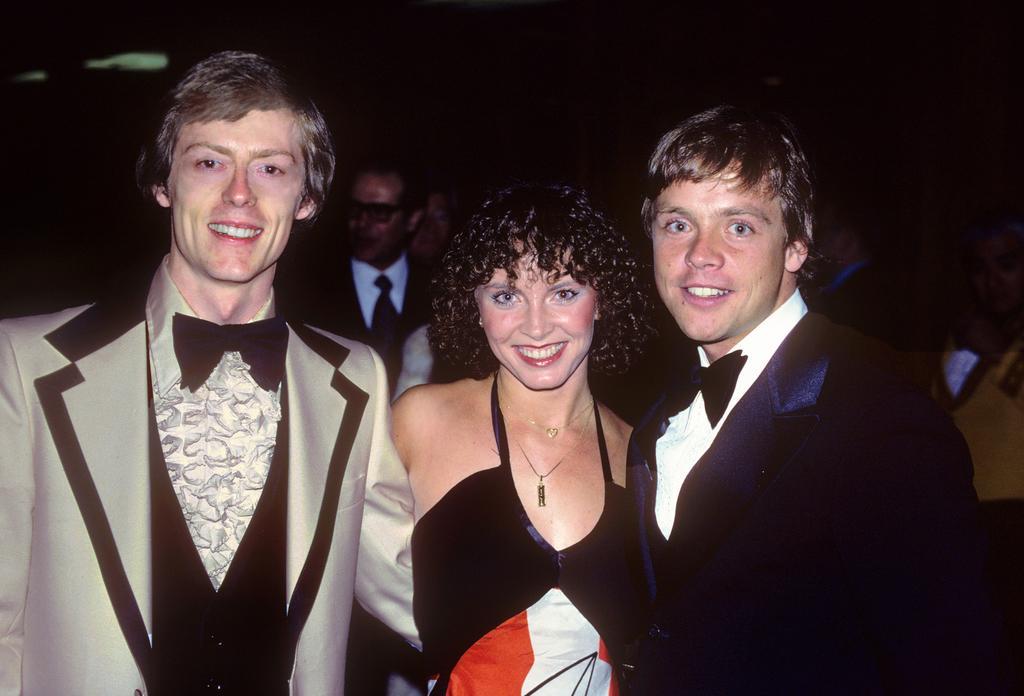How would you summarize this image in a sentence or two? In this image, we can see three people are standing. They are watching and smiling. Background we can see few people and dark view. 